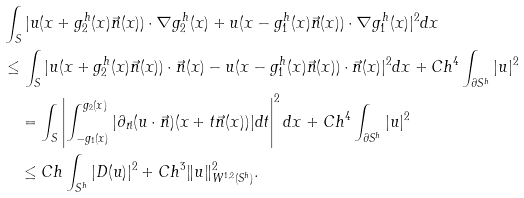Convert formula to latex. <formula><loc_0><loc_0><loc_500><loc_500>& \int _ { S } | u ( x + g _ { 2 } ^ { h } ( x ) \vec { n } ( x ) ) \cdot \nabla g _ { 2 } ^ { h } ( x ) + u ( x - g _ { 1 } ^ { h } ( x ) \vec { n } ( x ) ) \cdot \nabla g _ { 1 } ^ { h } ( x ) | ^ { 2 } d x \\ & \leq \int _ { S } | u ( x + g _ { 2 } ^ { h } ( x ) \vec { n } ( x ) ) \cdot \vec { n } ( x ) - u ( x - g _ { 1 } ^ { h } ( x ) \vec { n } ( x ) ) \cdot \vec { n } ( x ) | ^ { 2 } d x + C h ^ { 4 } \int _ { \partial S ^ { h } } | u | ^ { 2 } \\ & \quad = \int _ { S } \left | \int _ { - g _ { 1 } ( x ) } ^ { g _ { 2 } ( x ) } | \partial _ { \vec { n } } ( u \cdot \vec { n } ) ( x + t \vec { n } ( x ) ) | d t \right | ^ { 2 } d x + C h ^ { 4 } \int _ { \partial S ^ { h } } | u | ^ { 2 } \\ & \quad \leq C h \int _ { S ^ { h } } | D ( u ) | ^ { 2 } + C h ^ { 3 } \| u \| _ { W ^ { 1 , 2 } ( S ^ { h } ) } ^ { 2 } .</formula> 